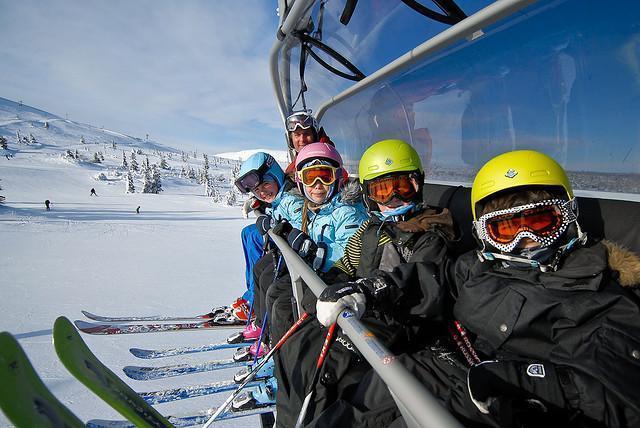How many ski are there?
Give a very brief answer. 2. How many people are there?
Give a very brief answer. 5. 